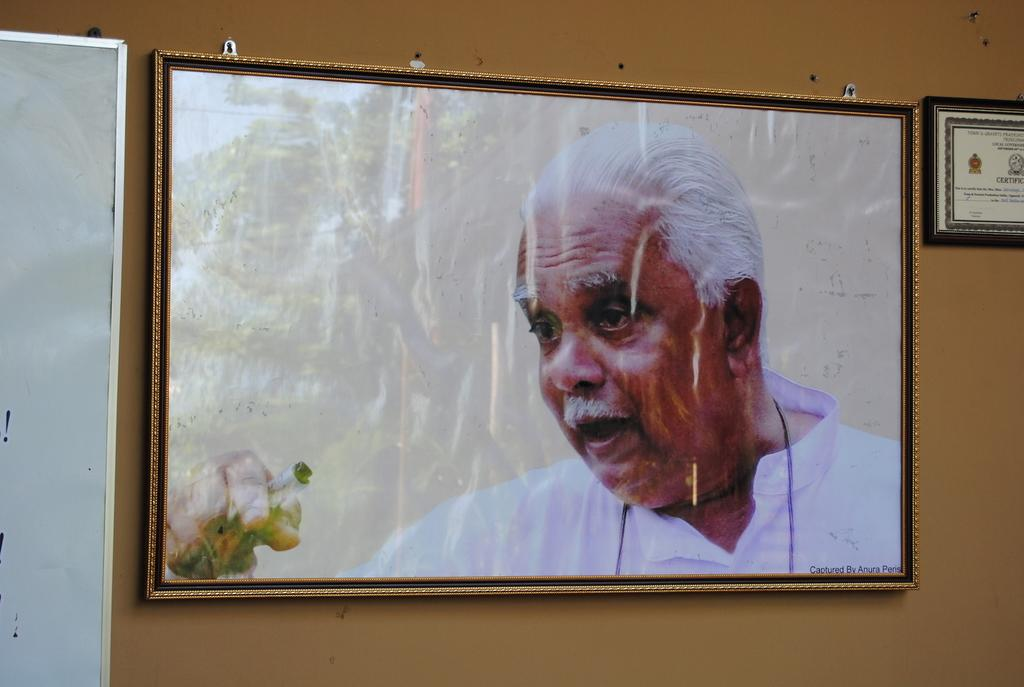What is hanging on the wall in the image? There are frames and a board on the wall. What can be seen inside the frames? The frame contains an image of a man and an image of a tree. What is the board used for? The purpose of the board is not specified in the image. How many beds are visible in the image? There are no beds present in the image. What thoughts does the man in the frame have about the wilderness? The image of the man does not convey any thoughts, and there is no mention of wilderness in the image. 